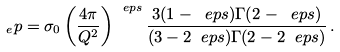Convert formula to latex. <formula><loc_0><loc_0><loc_500><loc_500>_ { e } p = \sigma _ { 0 } \left ( \frac { 4 \pi } { Q ^ { 2 } } \right ) ^ { \ e p s } \frac { 3 ( 1 - \ e p s ) \Gamma ( 2 - \ e p s ) } { ( 3 - 2 \ e p s ) \Gamma ( 2 - 2 \ e p s ) } \, .</formula> 